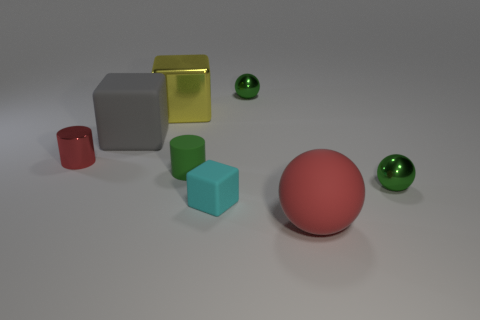Subtract all small green shiny balls. How many balls are left? 1 Subtract all red cylinders. How many cylinders are left? 1 Add 1 rubber cylinders. How many objects exist? 9 Subtract all cylinders. How many objects are left? 6 Subtract all purple spheres. How many green cylinders are left? 1 Subtract all gray shiny cylinders. Subtract all metallic spheres. How many objects are left? 6 Add 2 large objects. How many large objects are left? 5 Add 7 large purple balls. How many large purple balls exist? 7 Subtract 1 green cylinders. How many objects are left? 7 Subtract 2 spheres. How many spheres are left? 1 